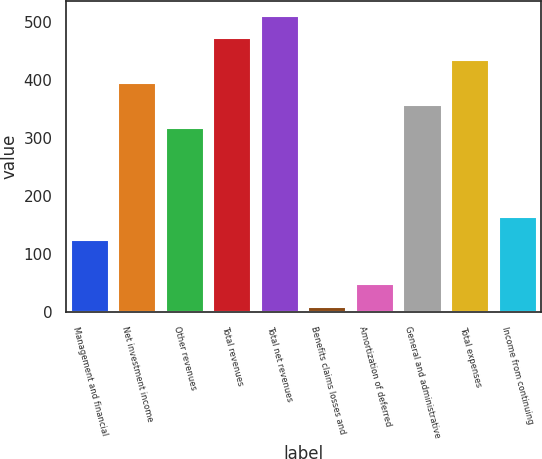<chart> <loc_0><loc_0><loc_500><loc_500><bar_chart><fcel>Management and financial<fcel>Net investment income<fcel>Other revenues<fcel>Total revenues<fcel>Total net revenues<fcel>Benefits claims losses and<fcel>Amortization of deferred<fcel>General and administrative<fcel>Total expenses<fcel>Income from continuing<nl><fcel>124.8<fcel>395<fcel>317.8<fcel>472.2<fcel>510.8<fcel>9<fcel>47.6<fcel>356.4<fcel>433.6<fcel>163.4<nl></chart> 